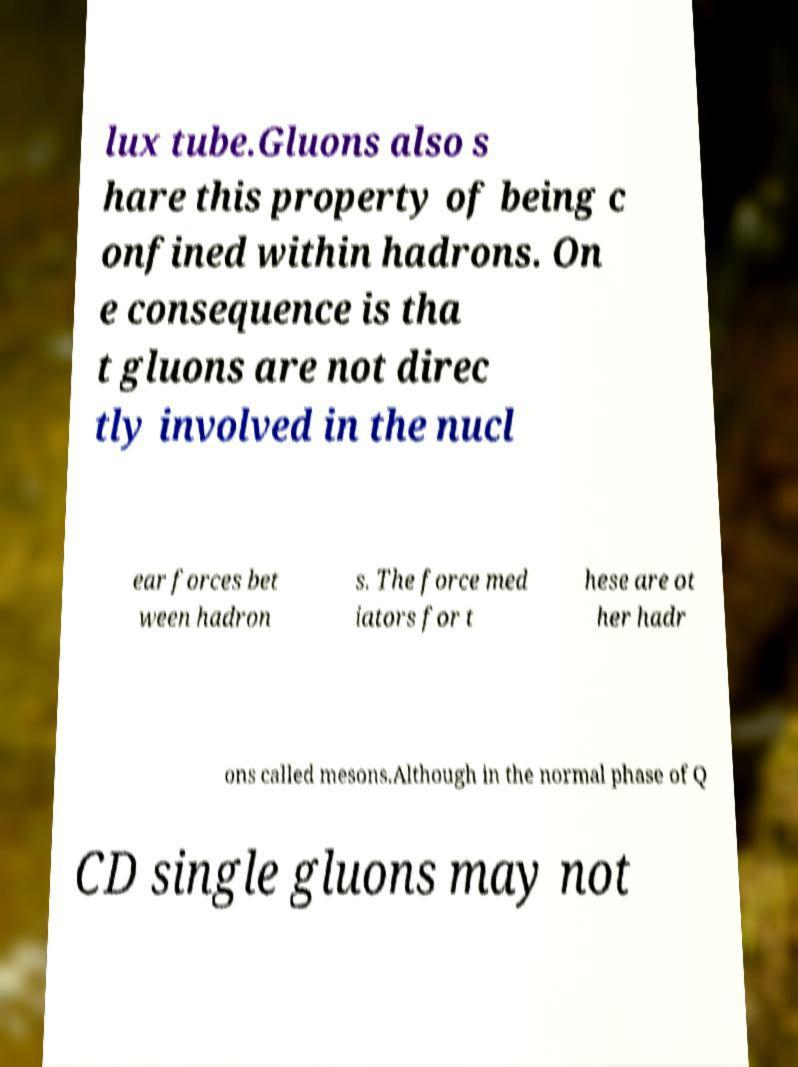Please read and relay the text visible in this image. What does it say? lux tube.Gluons also s hare this property of being c onfined within hadrons. On e consequence is tha t gluons are not direc tly involved in the nucl ear forces bet ween hadron s. The force med iators for t hese are ot her hadr ons called mesons.Although in the normal phase of Q CD single gluons may not 